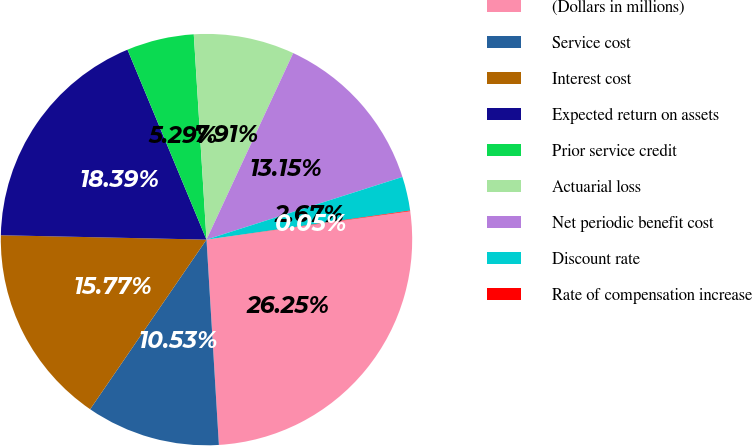<chart> <loc_0><loc_0><loc_500><loc_500><pie_chart><fcel>(Dollars in millions)<fcel>Service cost<fcel>Interest cost<fcel>Expected return on assets<fcel>Prior service credit<fcel>Actuarial loss<fcel>Net periodic benefit cost<fcel>Discount rate<fcel>Rate of compensation increase<nl><fcel>26.25%<fcel>10.53%<fcel>15.77%<fcel>18.39%<fcel>5.29%<fcel>7.91%<fcel>13.15%<fcel>2.67%<fcel>0.05%<nl></chart> 